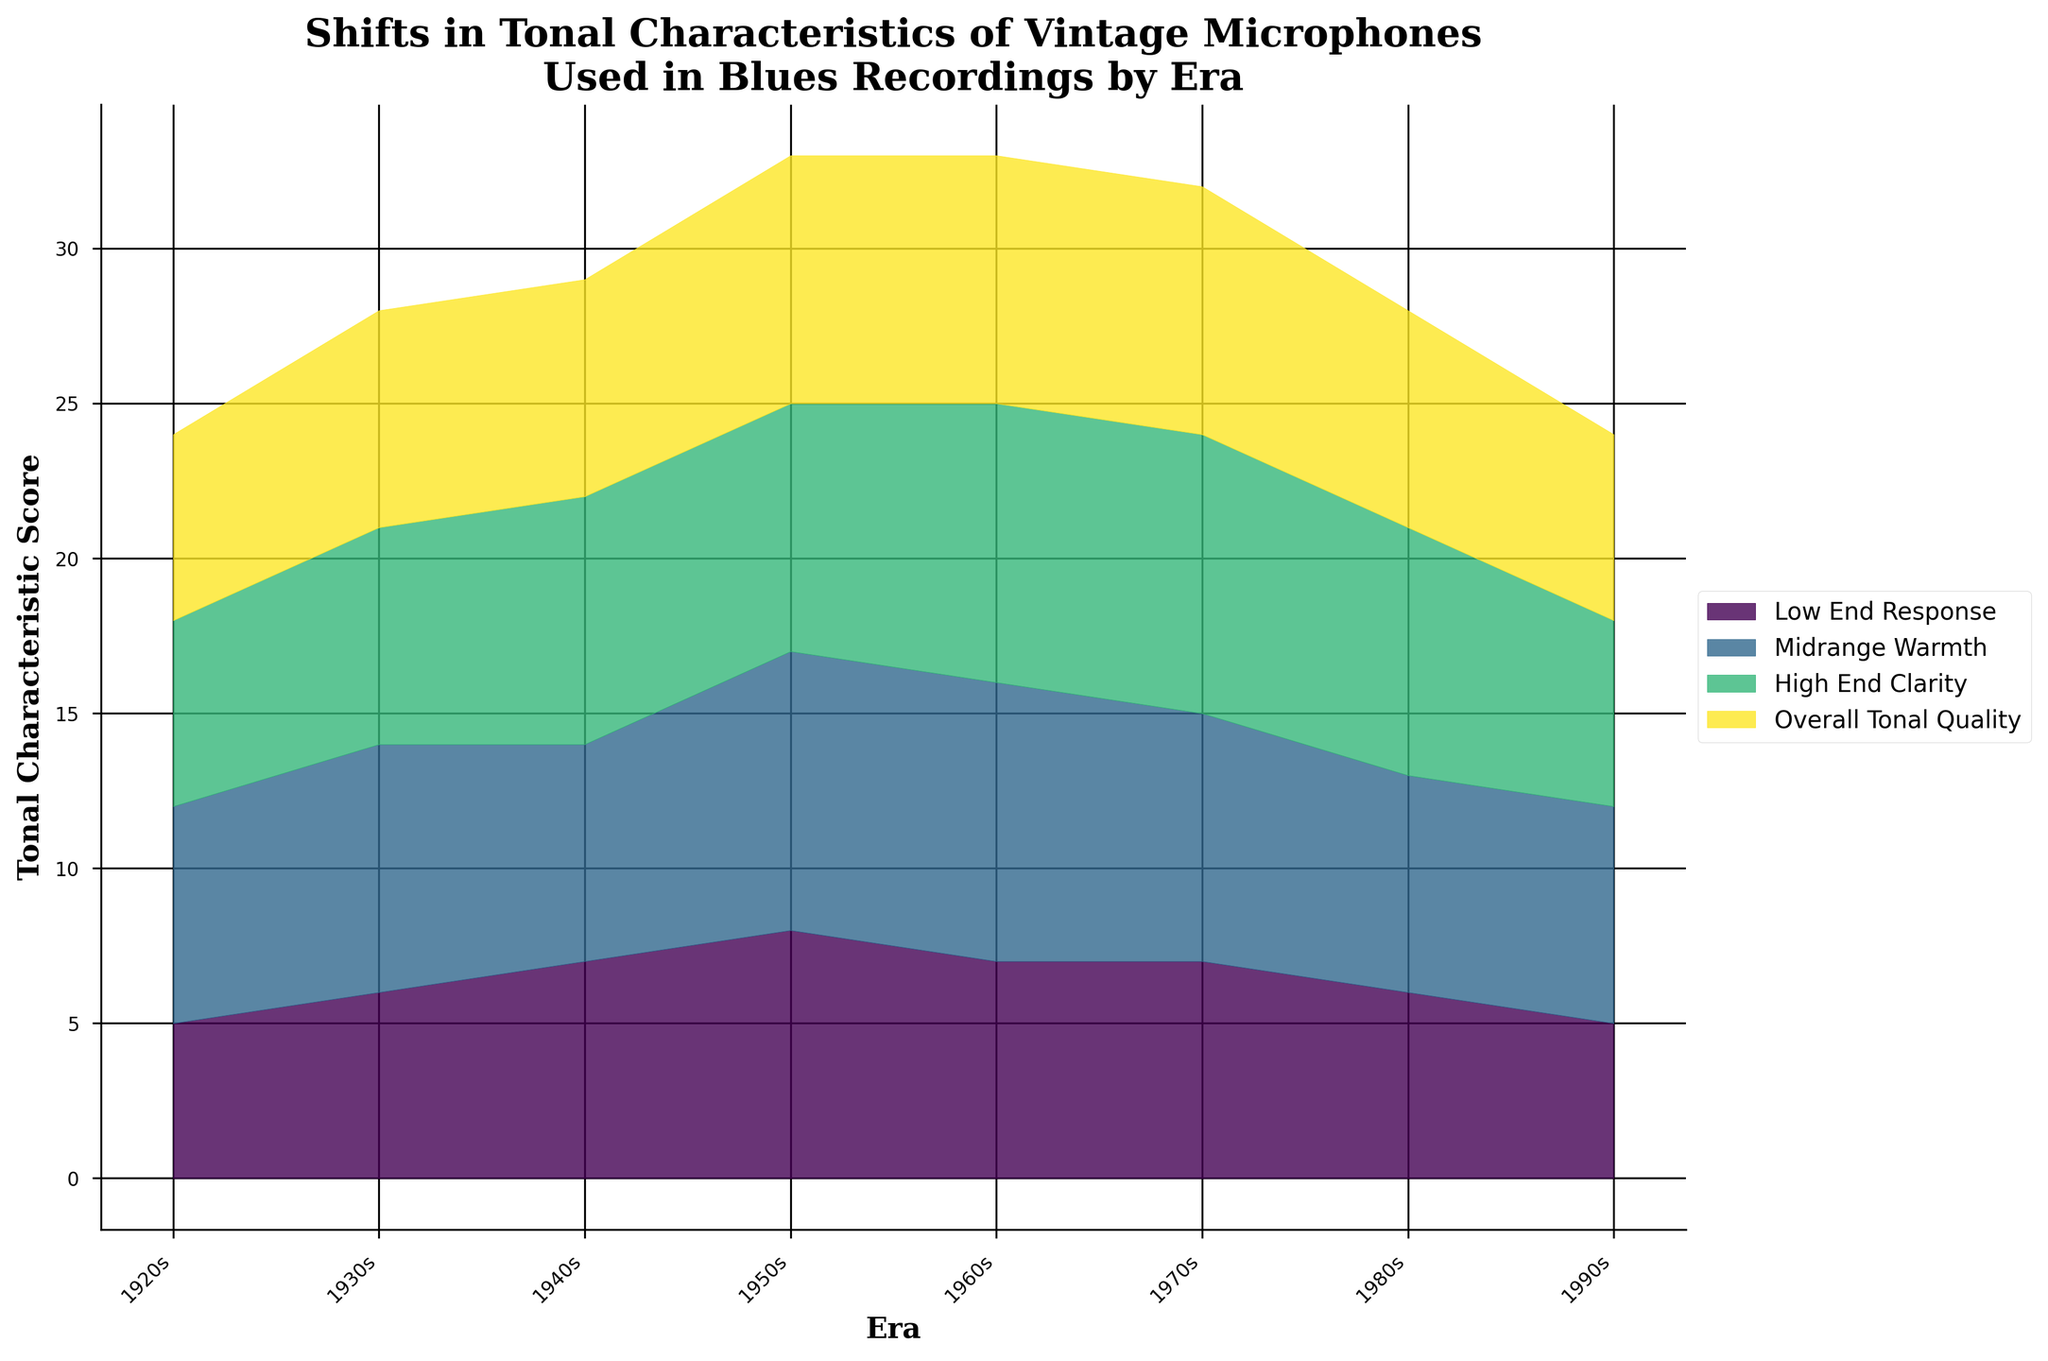How many eras are represented in the figure? Count the number of distinct eras marked on the x-axis.
Answer: 8 What is the title of the figure? Read the title at the top of the figure.
Answer: Shifts in Tonal Characteristics of Vintage Microphones Used in Blues Recordings by Era Which tonal characteristic shows the highest overall score in the 1950s? Check the fill colors corresponding to each characteristic and read the highest stacked value for the 1950s.
Answer: Midrange Warmth Compare the Low End Response between the 1920s and the 1970s. Which era had a higher score? Find the Low End Response (first layer from the bottom) for both eras and compare their heights.
Answer: 1970s What is the trend in High End Clarity from the 1920s to the 1980s? Observe the shape and color corresponding to High End Clarity and note how it changes over the eras.
Answer: Increasing trend By how much does the Overall Tonal Quality change from the 1920s to the 1960s? Check the height of Overall Tonal Quality in the 1920s and in the 1960s and calculate the difference.
Answer: +2 Which era has the highest cumulative score for all tonal characteristics? Sum up the heights of all layers for each era and find the highest total.
Answer: 1950s Are there any eras where Midrange Warmth exceeds 8? If yes, which eras? Identify the height of the Midrange Warmth layer and see if it exceeds the value of 8 for any eras.
Answer: 1950s, 1960s In which era do we observe a decrease in High End Clarity compared to the previous era? Compare the heights of High End Clarity between consecutive eras and identify any decrease.
Answer: 1990s Which microphone model from the 1940s is displayed on the figure? Refer to the x-axis labels for the 1940s to find the microphone model.
Answer: Shure 55 Unidyne 